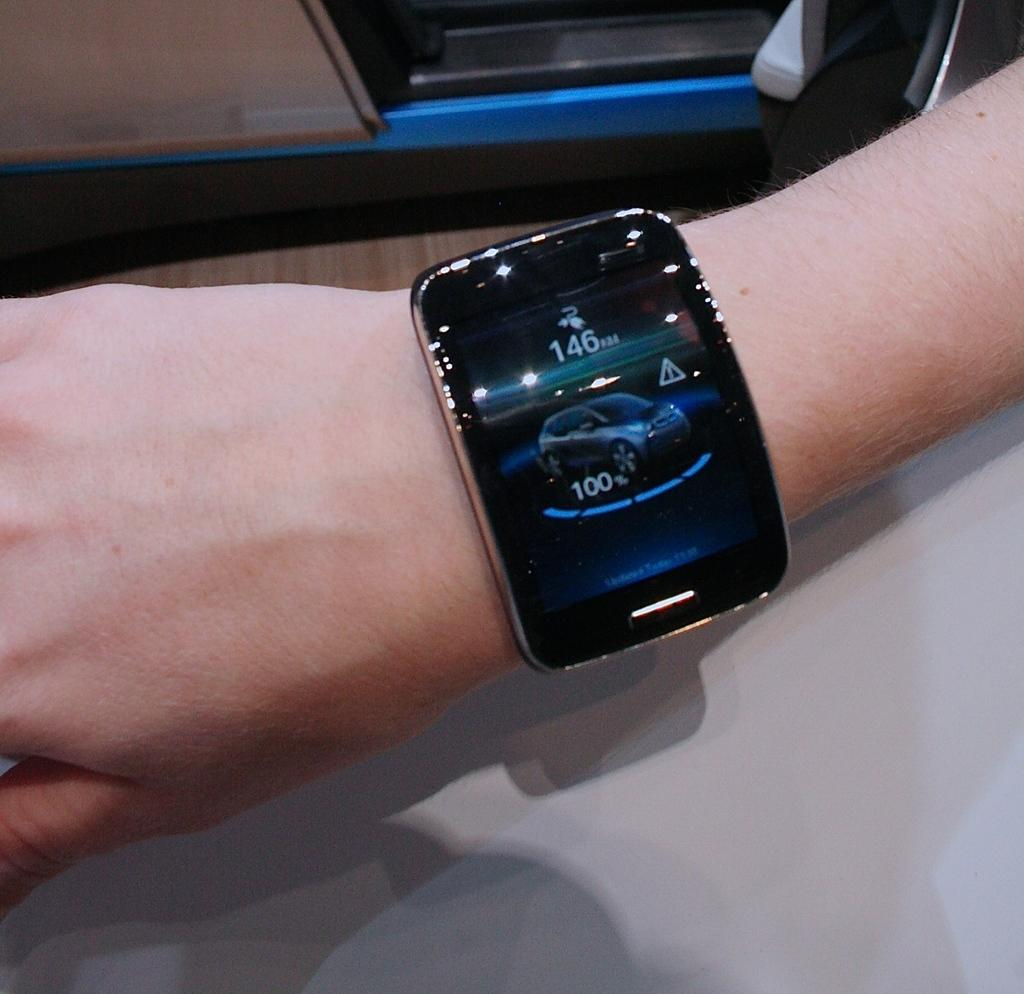Provide a one-sentence caption for the provided image. A person's watch shows an image of a car and the numbers 146 and 100. 